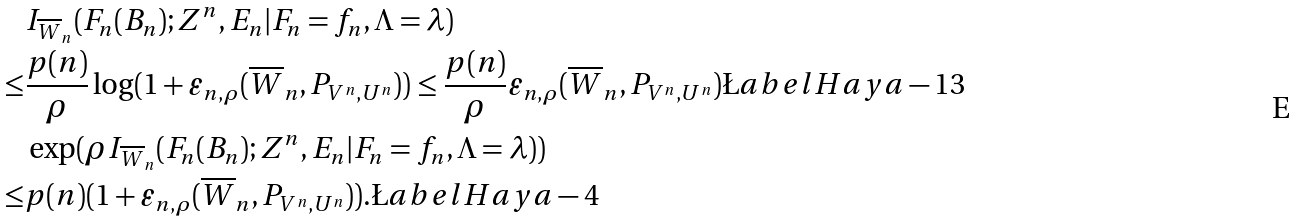<formula> <loc_0><loc_0><loc_500><loc_500>& I _ { \overline { W } _ { n } } ( F _ { n } ( B _ { n } ) ; Z ^ { n } , E _ { n } | F _ { n } = f _ { n } , \Lambda = \lambda ) \\ \leq & \frac { p ( n ) } { \rho } \log ( 1 + \varepsilon _ { n , \rho } ( \overline { W } _ { n } , P _ { V ^ { n } , U ^ { n } } ) ) \leq \frac { p ( n ) } { \rho } \varepsilon _ { n , \rho } ( \overline { W } _ { n } , P _ { V ^ { n } , U ^ { n } } ) \L a b e l { H a y a - 1 3 } \\ & \exp ( \rho I _ { \overline { W } _ { n } } ( F _ { n } ( B _ { n } ) ; Z ^ { n } , E _ { n } | F _ { n } = f _ { n } , \Lambda = \lambda ) ) \\ \leq & p ( n ) ( 1 + \varepsilon _ { n , \rho } ( \overline { W } _ { n } , P _ { V ^ { n } , U ^ { n } } ) ) . \L a b e l { H a y a - 4 }</formula> 